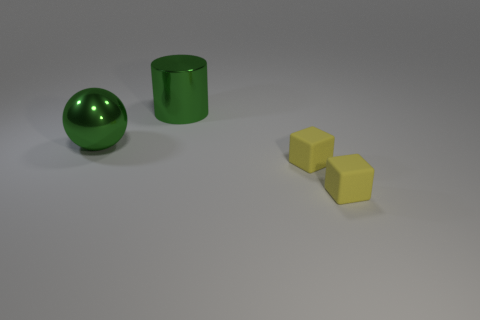Subtract all cyan spheres. Subtract all purple cubes. How many spheres are left? 1 Add 4 yellow rubber things. How many objects exist? 8 Subtract all balls. How many objects are left? 3 Add 3 green metal balls. How many green metal balls exist? 4 Subtract 0 brown balls. How many objects are left? 4 Subtract all large green metal balls. Subtract all shiny cylinders. How many objects are left? 2 Add 3 green metal balls. How many green metal balls are left? 4 